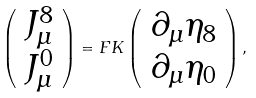<formula> <loc_0><loc_0><loc_500><loc_500>\left ( \begin{array} { c } { { J _ { \mu } ^ { 8 } } } \\ { { J _ { \mu } ^ { 0 } } } \end{array} \right ) = F K \left ( \begin{array} { c } { { \partial _ { \mu } \eta _ { 8 } } } \\ { { \partial _ { \mu } \eta _ { 0 } } } \end{array} \right ) ,</formula> 